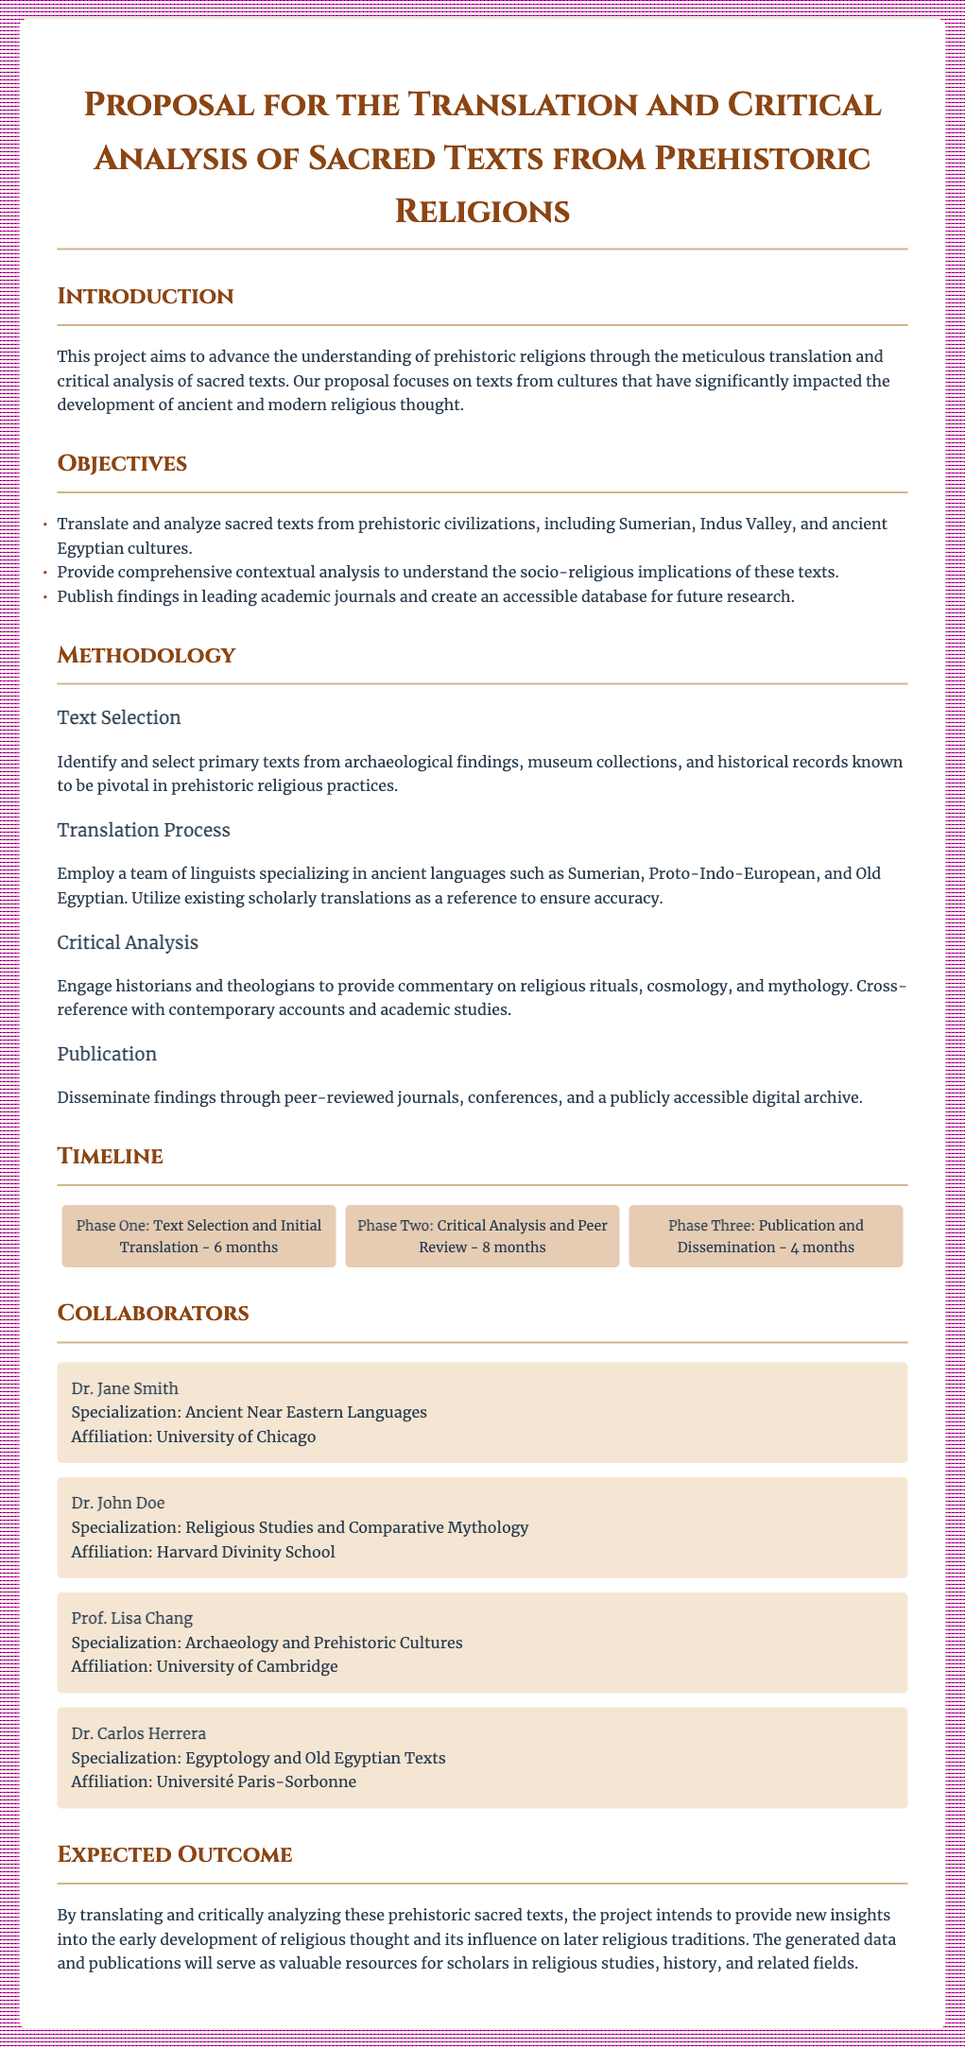What is the title of the proposal? The title is explicitly stated at the beginning of the document, which is about translating and analyzing ancient religious texts.
Answer: Proposal for the Translation and Critical Analysis of Sacred Texts from Prehistoric Religions Who is the collaborator specializing in Egyptology? This information is found in the Collaborators section, where each collaborator's specialization is listed.
Answer: Dr. Carlos Herrera How long is the critical analysis and peer review phase? The duration of each project phase is clearly laid out in the timeline section of the document.
Answer: 8 months What are the three phases listed in the timeline? The phases detail the project's progress and are included within the timeline subsection.
Answer: Phase One, Phase Two, Phase Three Which civilization's sacred texts are included in the objectives? The objectives section outlines the focus of the translation and analysis work on various civilizations.
Answer: Sumerian, Indus Valley, and ancient Egyptian cultures What type of publication is planned for the findings? The publication approach for the research findings is briefly described in the publication subsection of the methodology.
Answer: Peer-reviewed journals Who is affiliated with Harvard Divinity School? This information is found in the Collaborators section, which lists their affiliations alongside their specializations.
Answer: Dr. John Doe What is the expected outcome of the project? The expected outcomes are summarized in the corresponding section, indicating the project's ultimate goals.
Answer: New insights into early development of religious thought 